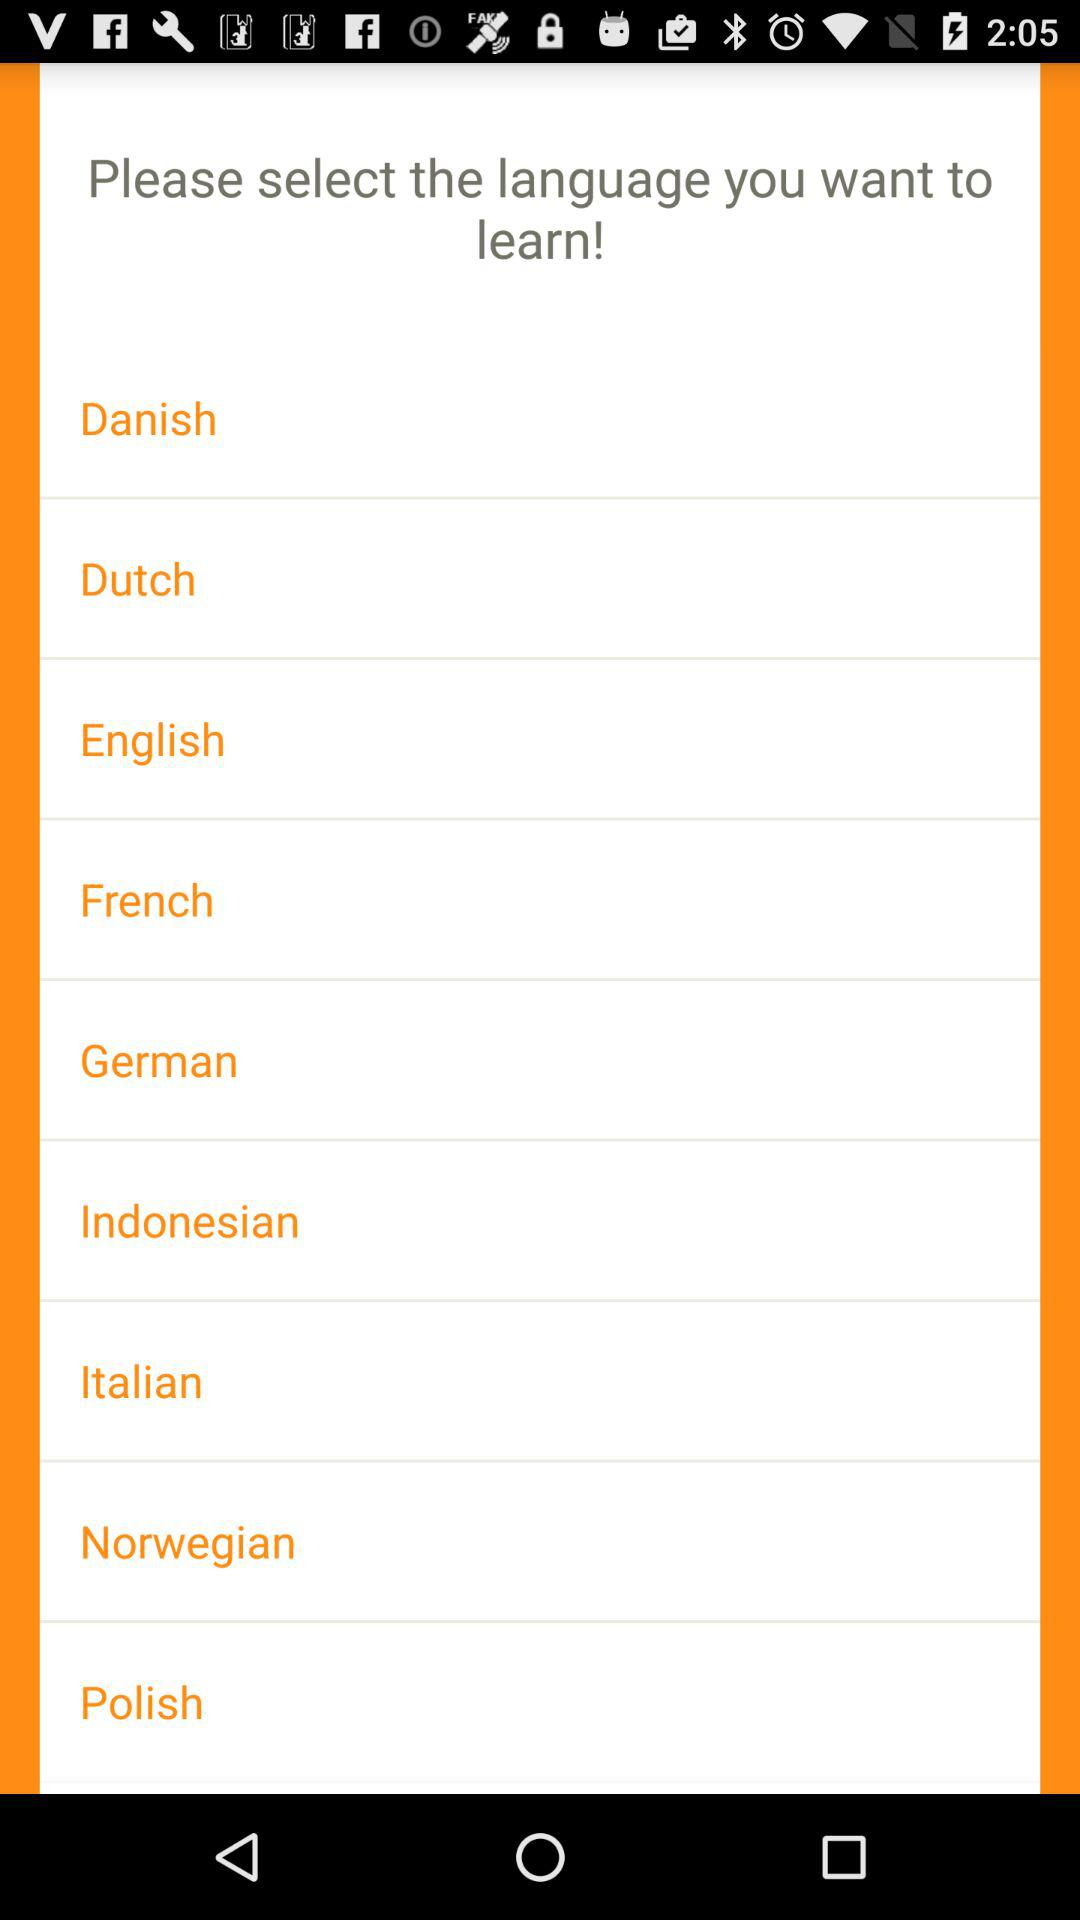How many languages are available to learn?
Answer the question using a single word or phrase. 9 